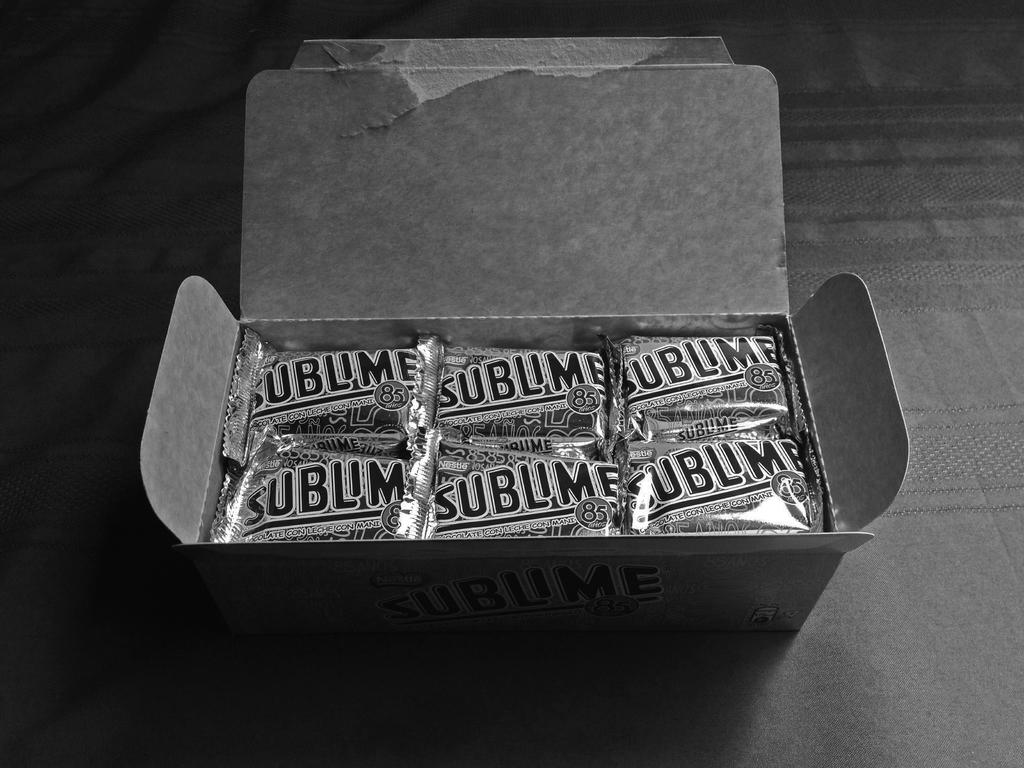What object is present in the image? There is a box in the image. What is inside the box? The box contains food items. How are the food items packaged or protected? The food items are wrapped in a cover. What type of gold jewelry can be seen in the image? There is no gold jewelry present in the image; it only contains a box with wrapped food items. 